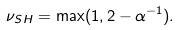<formula> <loc_0><loc_0><loc_500><loc_500>\nu _ { S H } = \max ( 1 , 2 - \alpha ^ { - 1 } ) .</formula> 